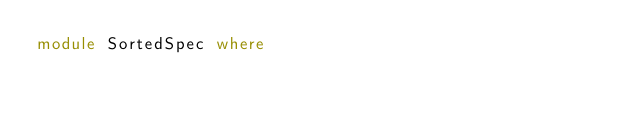Convert code to text. <code><loc_0><loc_0><loc_500><loc_500><_Haskell_>module SortedSpec where

</code> 